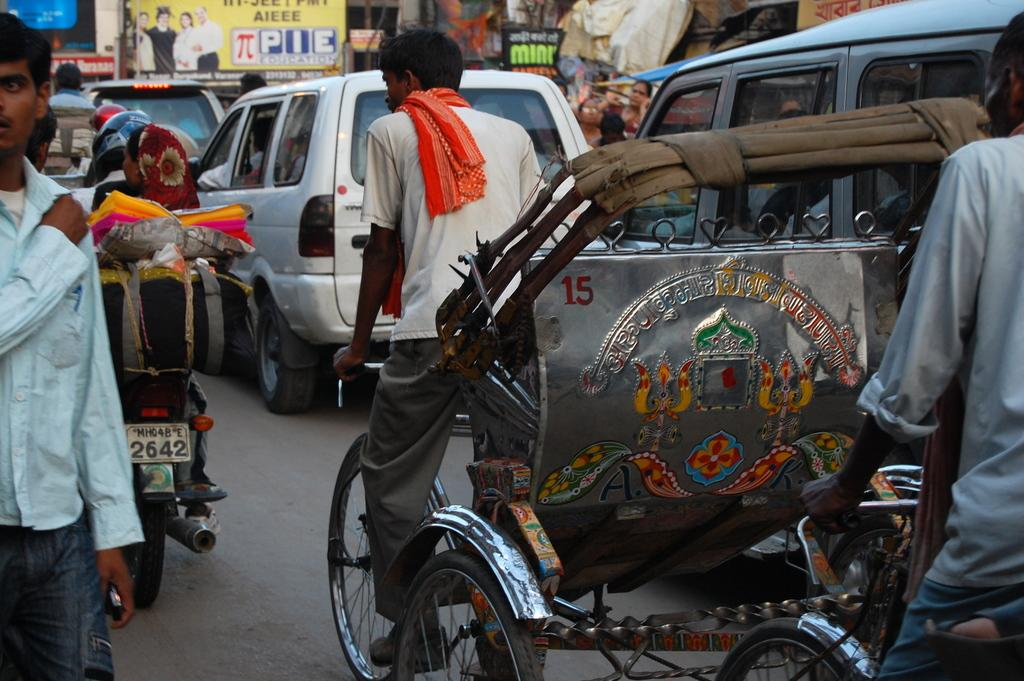What are the people in the image doing? There is a group of people riding vehicles on the road, and another group of people standing. What can be seen in the background of the image? There are boards and houses visible in the background. What type of ring is being passed around among the family members in the image? There is no family or ring present in the image; it features a group of people riding vehicles and another group standing, with boards and houses visible in the background. 